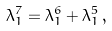Convert formula to latex. <formula><loc_0><loc_0><loc_500><loc_500>\lambda _ { 1 } ^ { 7 } = \lambda _ { 1 } ^ { 6 } + \lambda _ { 1 } ^ { 5 } \, ,</formula> 